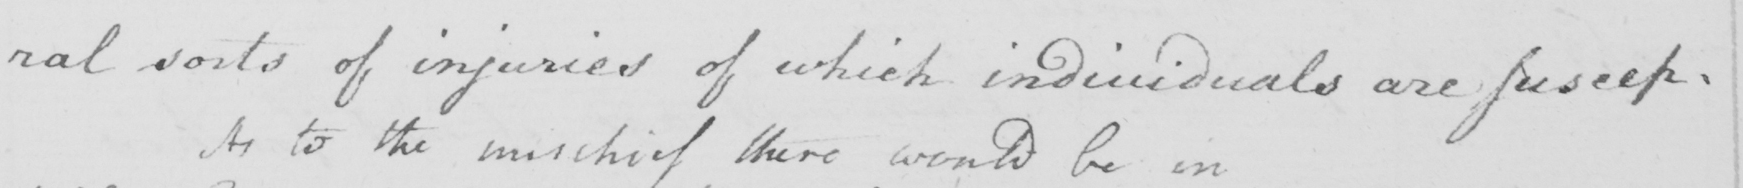Transcribe the text shown in this historical manuscript line. : ral sorts of injuries of which individuals are suscep= 